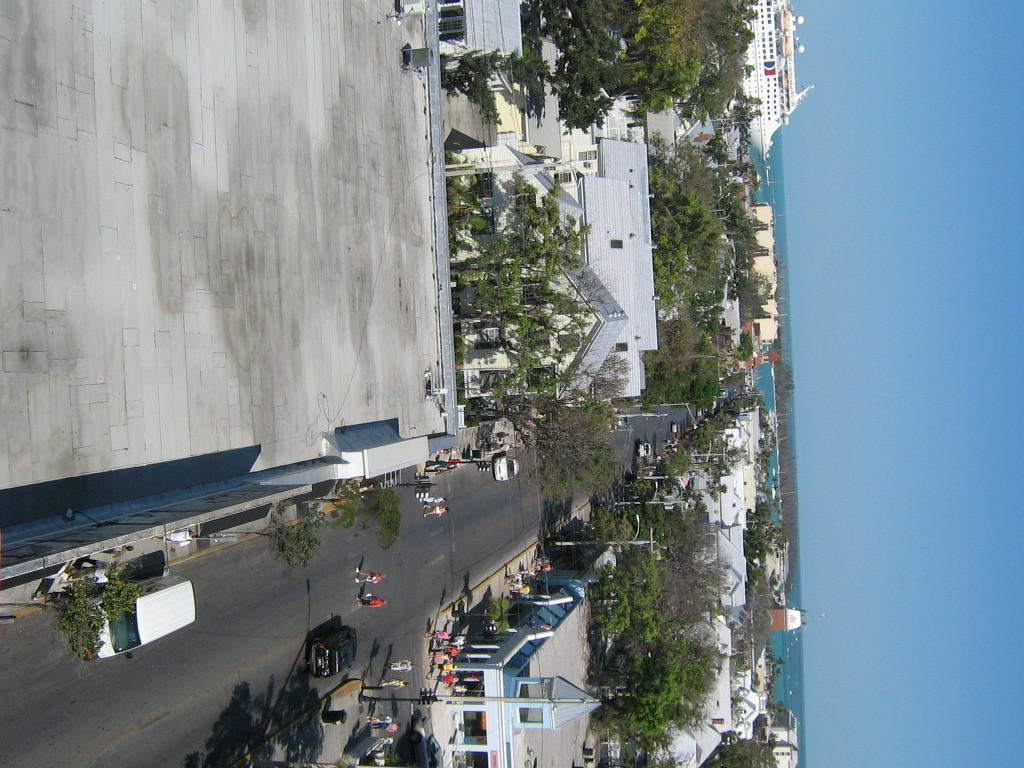In one or two sentences, can you explain what this image depicts? This image is in right direction. At the bottom there is a road and I can see few vehicles on the road. On both sides of the road there are many buildings and trees. At the top of the image there is a ship. On the right side, I can see the sky in blue color. 